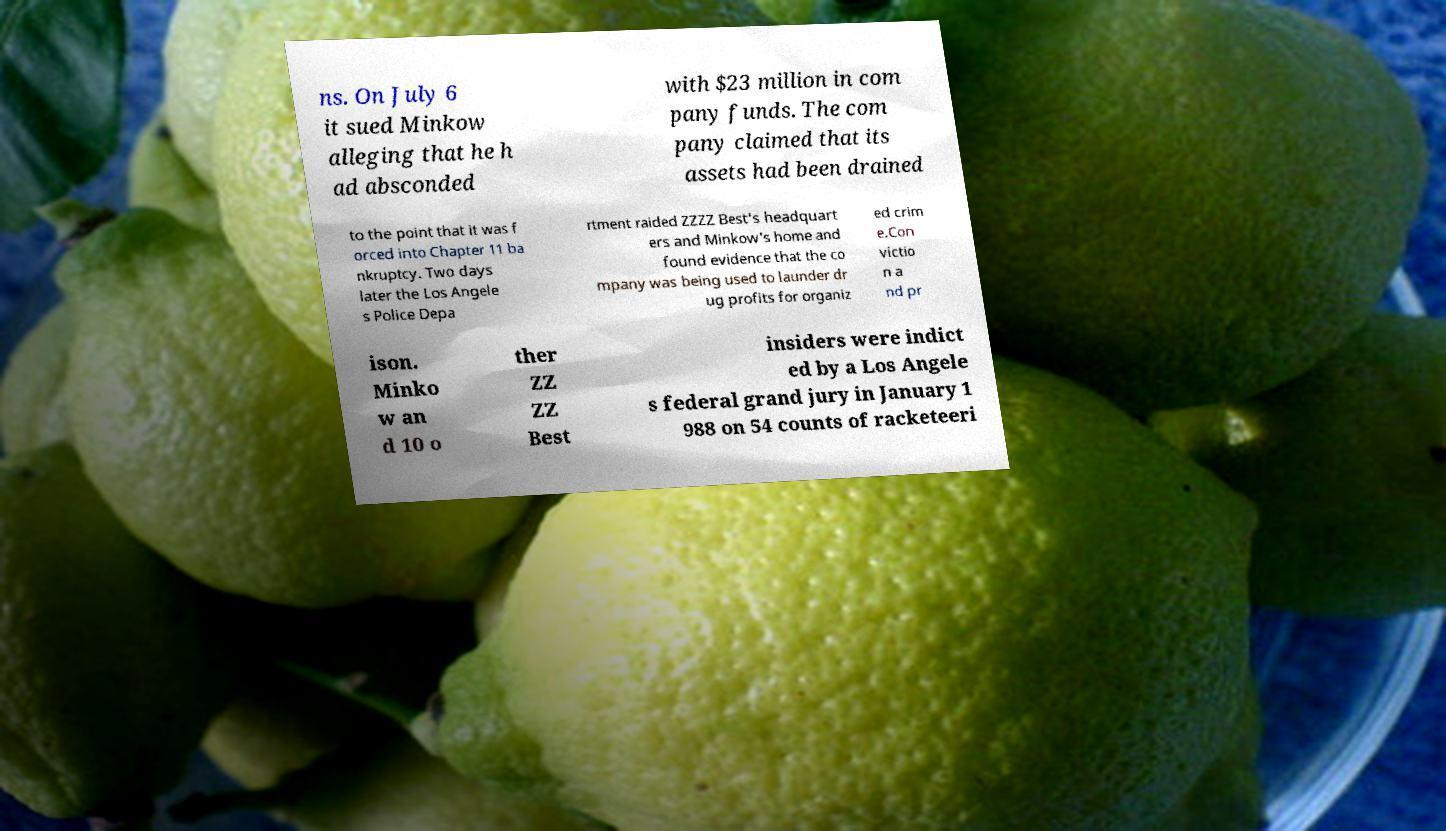I need the written content from this picture converted into text. Can you do that? ns. On July 6 it sued Minkow alleging that he h ad absconded with $23 million in com pany funds. The com pany claimed that its assets had been drained to the point that it was f orced into Chapter 11 ba nkruptcy. Two days later the Los Angele s Police Depa rtment raided ZZZZ Best's headquart ers and Minkow's home and found evidence that the co mpany was being used to launder dr ug profits for organiz ed crim e.Con victio n a nd pr ison. Minko w an d 10 o ther ZZ ZZ Best insiders were indict ed by a Los Angele s federal grand jury in January 1 988 on 54 counts of racketeeri 